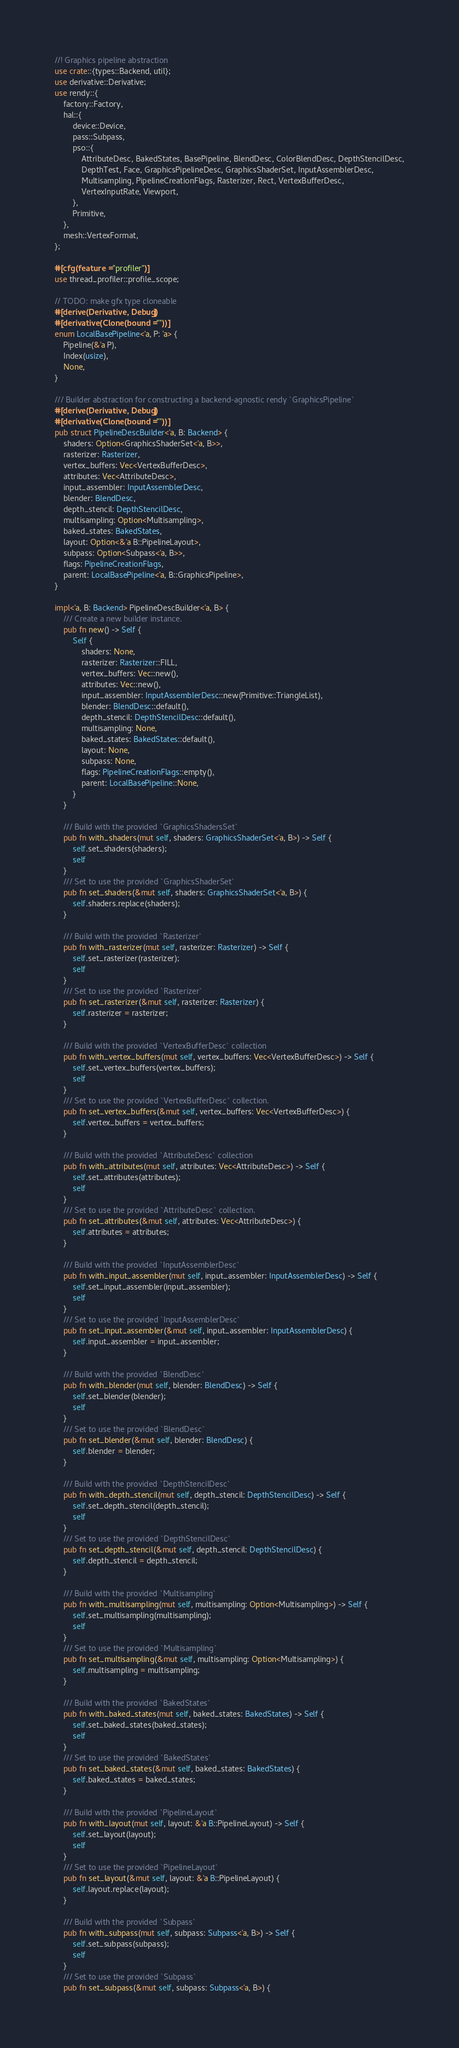Convert code to text. <code><loc_0><loc_0><loc_500><loc_500><_Rust_>//! Graphics pipeline abstraction
use crate::{types::Backend, util};
use derivative::Derivative;
use rendy::{
    factory::Factory,
    hal::{
        device::Device,
        pass::Subpass,
        pso::{
            AttributeDesc, BakedStates, BasePipeline, BlendDesc, ColorBlendDesc, DepthStencilDesc,
            DepthTest, Face, GraphicsPipelineDesc, GraphicsShaderSet, InputAssemblerDesc,
            Multisampling, PipelineCreationFlags, Rasterizer, Rect, VertexBufferDesc,
            VertexInputRate, Viewport,
        },
        Primitive,
    },
    mesh::VertexFormat,
};

#[cfg(feature = "profiler")]
use thread_profiler::profile_scope;

// TODO: make gfx type cloneable
#[derive(Derivative, Debug)]
#[derivative(Clone(bound = ""))]
enum LocalBasePipeline<'a, P: 'a> {
    Pipeline(&'a P),
    Index(usize),
    None,
}

/// Builder abstraction for constructing a backend-agnostic rendy `GraphicsPipeline`
#[derive(Derivative, Debug)]
#[derivative(Clone(bound = ""))]
pub struct PipelineDescBuilder<'a, B: Backend> {
    shaders: Option<GraphicsShaderSet<'a, B>>,
    rasterizer: Rasterizer,
    vertex_buffers: Vec<VertexBufferDesc>,
    attributes: Vec<AttributeDesc>,
    input_assembler: InputAssemblerDesc,
    blender: BlendDesc,
    depth_stencil: DepthStencilDesc,
    multisampling: Option<Multisampling>,
    baked_states: BakedStates,
    layout: Option<&'a B::PipelineLayout>,
    subpass: Option<Subpass<'a, B>>,
    flags: PipelineCreationFlags,
    parent: LocalBasePipeline<'a, B::GraphicsPipeline>,
}

impl<'a, B: Backend> PipelineDescBuilder<'a, B> {
    /// Create a new builder instance.
    pub fn new() -> Self {
        Self {
            shaders: None,
            rasterizer: Rasterizer::FILL,
            vertex_buffers: Vec::new(),
            attributes: Vec::new(),
            input_assembler: InputAssemblerDesc::new(Primitive::TriangleList),
            blender: BlendDesc::default(),
            depth_stencil: DepthStencilDesc::default(),
            multisampling: None,
            baked_states: BakedStates::default(),
            layout: None,
            subpass: None,
            flags: PipelineCreationFlags::empty(),
            parent: LocalBasePipeline::None,
        }
    }

    /// Build with the provided `GraphicsShadersSet`
    pub fn with_shaders(mut self, shaders: GraphicsShaderSet<'a, B>) -> Self {
        self.set_shaders(shaders);
        self
    }
    /// Set to use the provided `GraphicsShaderSet`
    pub fn set_shaders(&mut self, shaders: GraphicsShaderSet<'a, B>) {
        self.shaders.replace(shaders);
    }

    /// Build with the provided `Rasterizer`
    pub fn with_rasterizer(mut self, rasterizer: Rasterizer) -> Self {
        self.set_rasterizer(rasterizer);
        self
    }
    /// Set to use the provided `Rasterizer`
    pub fn set_rasterizer(&mut self, rasterizer: Rasterizer) {
        self.rasterizer = rasterizer;
    }

    /// Build with the provided `VertexBufferDesc` collection
    pub fn with_vertex_buffers(mut self, vertex_buffers: Vec<VertexBufferDesc>) -> Self {
        self.set_vertex_buffers(vertex_buffers);
        self
    }
    /// Set to use the provided `VertexBufferDesc` collection.
    pub fn set_vertex_buffers(&mut self, vertex_buffers: Vec<VertexBufferDesc>) {
        self.vertex_buffers = vertex_buffers;
    }

    /// Build with the provided `AttributeDesc` collection
    pub fn with_attributes(mut self, attributes: Vec<AttributeDesc>) -> Self {
        self.set_attributes(attributes);
        self
    }
    /// Set to use the provided `AttributeDesc` collection.
    pub fn set_attributes(&mut self, attributes: Vec<AttributeDesc>) {
        self.attributes = attributes;
    }

    /// Build with the provided `InputAssemblerDesc`
    pub fn with_input_assembler(mut self, input_assembler: InputAssemblerDesc) -> Self {
        self.set_input_assembler(input_assembler);
        self
    }
    /// Set to use the provided `InputAssemblerDesc`
    pub fn set_input_assembler(&mut self, input_assembler: InputAssemblerDesc) {
        self.input_assembler = input_assembler;
    }

    /// Build with the provided `BlendDesc`
    pub fn with_blender(mut self, blender: BlendDesc) -> Self {
        self.set_blender(blender);
        self
    }
    /// Set to use the provided `BlendDesc`
    pub fn set_blender(&mut self, blender: BlendDesc) {
        self.blender = blender;
    }

    /// Build with the provided `DepthStencilDesc`
    pub fn with_depth_stencil(mut self, depth_stencil: DepthStencilDesc) -> Self {
        self.set_depth_stencil(depth_stencil);
        self
    }
    /// Set to use the provided `DepthStencilDesc`
    pub fn set_depth_stencil(&mut self, depth_stencil: DepthStencilDesc) {
        self.depth_stencil = depth_stencil;
    }

    /// Build with the provided `Multisampling`
    pub fn with_multisampling(mut self, multisampling: Option<Multisampling>) -> Self {
        self.set_multisampling(multisampling);
        self
    }
    /// Set to use the provided `Multisampling`
    pub fn set_multisampling(&mut self, multisampling: Option<Multisampling>) {
        self.multisampling = multisampling;
    }

    /// Build with the provided `BakedStates`
    pub fn with_baked_states(mut self, baked_states: BakedStates) -> Self {
        self.set_baked_states(baked_states);
        self
    }
    /// Set to use the provided `BakedStates`
    pub fn set_baked_states(&mut self, baked_states: BakedStates) {
        self.baked_states = baked_states;
    }

    /// Build with the provided `PipelineLayout`
    pub fn with_layout(mut self, layout: &'a B::PipelineLayout) -> Self {
        self.set_layout(layout);
        self
    }
    /// Set to use the provided `PipelineLayout`
    pub fn set_layout(&mut self, layout: &'a B::PipelineLayout) {
        self.layout.replace(layout);
    }

    /// Build with the provided `Subpass`
    pub fn with_subpass(mut self, subpass: Subpass<'a, B>) -> Self {
        self.set_subpass(subpass);
        self
    }
    /// Set to use the provided `Subpass`
    pub fn set_subpass(&mut self, subpass: Subpass<'a, B>) {</code> 